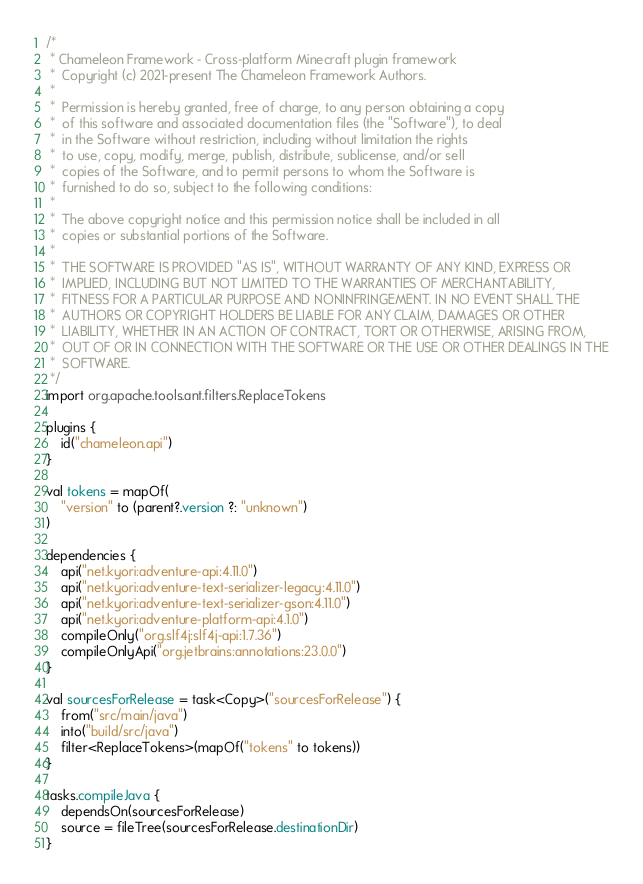Convert code to text. <code><loc_0><loc_0><loc_500><loc_500><_Kotlin_>/*
 * Chameleon Framework - Cross-platform Minecraft plugin framework
 *  Copyright (c) 2021-present The Chameleon Framework Authors.
 *
 *  Permission is hereby granted, free of charge, to any person obtaining a copy
 *  of this software and associated documentation files (the "Software"), to deal
 *  in the Software without restriction, including without limitation the rights
 *  to use, copy, modify, merge, publish, distribute, sublicense, and/or sell
 *  copies of the Software, and to permit persons to whom the Software is
 *  furnished to do so, subject to the following conditions:
 *
 *  The above copyright notice and this permission notice shall be included in all
 *  copies or substantial portions of the Software.
 *
 *  THE SOFTWARE IS PROVIDED "AS IS", WITHOUT WARRANTY OF ANY KIND, EXPRESS OR
 *  IMPLIED, INCLUDING BUT NOT LIMITED TO THE WARRANTIES OF MERCHANTABILITY,
 *  FITNESS FOR A PARTICULAR PURPOSE AND NONINFRINGEMENT. IN NO EVENT SHALL THE
 *  AUTHORS OR COPYRIGHT HOLDERS BE LIABLE FOR ANY CLAIM, DAMAGES OR OTHER
 *  LIABILITY, WHETHER IN AN ACTION OF CONTRACT, TORT OR OTHERWISE, ARISING FROM,
 *  OUT OF OR IN CONNECTION WITH THE SOFTWARE OR THE USE OR OTHER DEALINGS IN THE
 *  SOFTWARE.
 */
import org.apache.tools.ant.filters.ReplaceTokens

plugins {
    id("chameleon.api")
}

val tokens = mapOf(
    "version" to (parent?.version ?: "unknown")
)

dependencies {
    api("net.kyori:adventure-api:4.11.0")
    api("net.kyori:adventure-text-serializer-legacy:4.11.0")
    api("net.kyori:adventure-text-serializer-gson:4.11.0")
    api("net.kyori:adventure-platform-api:4.1.0")
    compileOnly("org.slf4j:slf4j-api:1.7.36")
    compileOnlyApi("org.jetbrains:annotations:23.0.0")
}

val sourcesForRelease = task<Copy>("sourcesForRelease") {
    from("src/main/java")
    into("build/src/java")
    filter<ReplaceTokens>(mapOf("tokens" to tokens))
}

tasks.compileJava {
    dependsOn(sourcesForRelease)
    source = fileTree(sourcesForRelease.destinationDir)
}</code> 